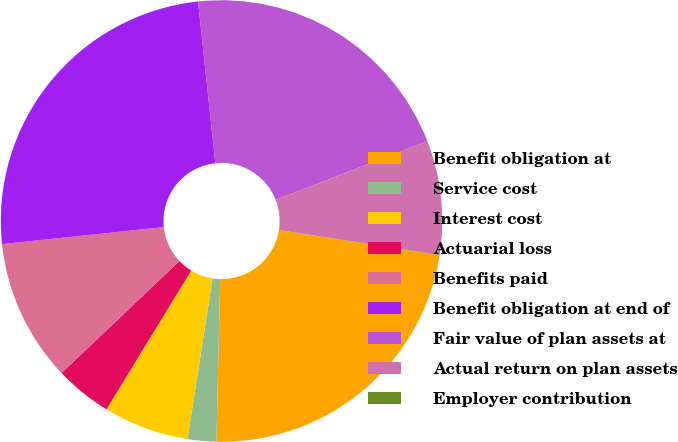<chart> <loc_0><loc_0><loc_500><loc_500><pie_chart><fcel>Benefit obligation at<fcel>Service cost<fcel>Interest cost<fcel>Actuarial loss<fcel>Benefits paid<fcel>Benefit obligation at end of<fcel>Fair value of plan assets at<fcel>Actual return on plan assets<fcel>Employer contribution<nl><fcel>22.89%<fcel>2.1%<fcel>6.26%<fcel>4.18%<fcel>10.42%<fcel>24.97%<fcel>20.81%<fcel>8.34%<fcel>0.03%<nl></chart> 